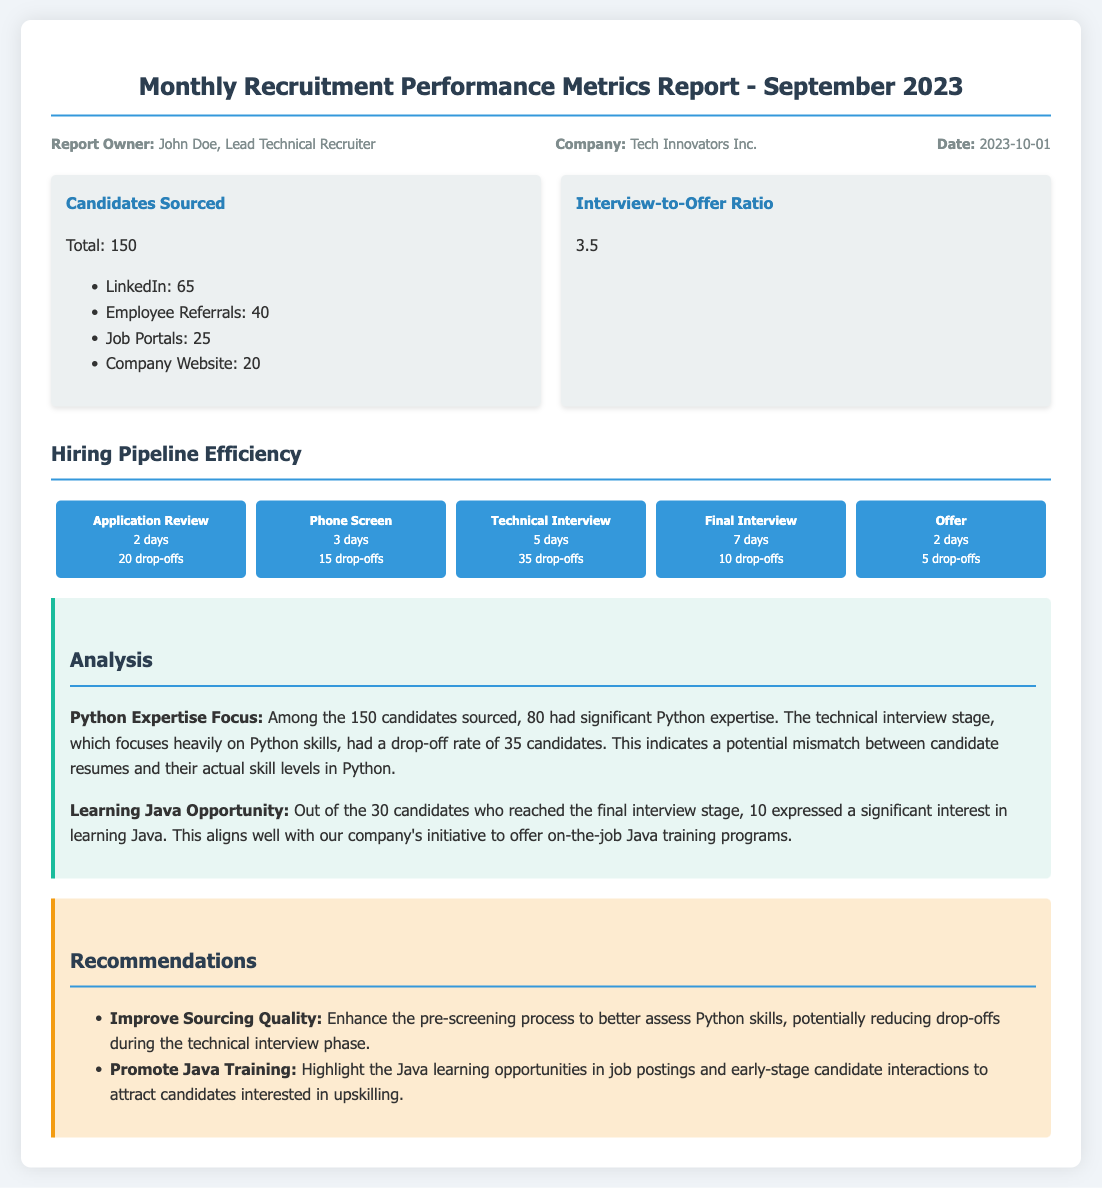What is the total number of candidates sourced? The total number of candidates sourced is given as 150 in the document.
Answer: 150 What is the interview-to-offer ratio? The interview-to-offer ratio is stated as 3.5 in the metrics section of the report.
Answer: 3.5 How many candidates with Python expertise were sourced? The document specifies that 80 of the candidates sourced had significant Python expertise.
Answer: 80 What was the number of drop-offs during the technical interview stage? The report indicates that there were 35 drop-offs during the technical interview stage.
Answer: 35 What is the total time taken for the application review stage? The total time taken for the application review stage is noted as 2 days in the hiring pipeline efficiency section.
Answer: 2 days What percentage of candidates interested in learning Java reached the final interview? Out of the 30 candidates who reached the final interview, 10 expressed interest in learning Java, indicating approximately 33.33%.
Answer: 10 What was the largest drop-off number in any hiring stage? The largest drop-off number is 35 during the technical interview stage.
Answer: 35 Who is the report owner? The report owner is identified as John Doe, Lead Technical Recruiter.
Answer: John Doe What recommendation is made to improve sourcing quality? The recommendation is to enhance the pre-screening process to better assess Python skills.
Answer: Improve Sourcing Quality 